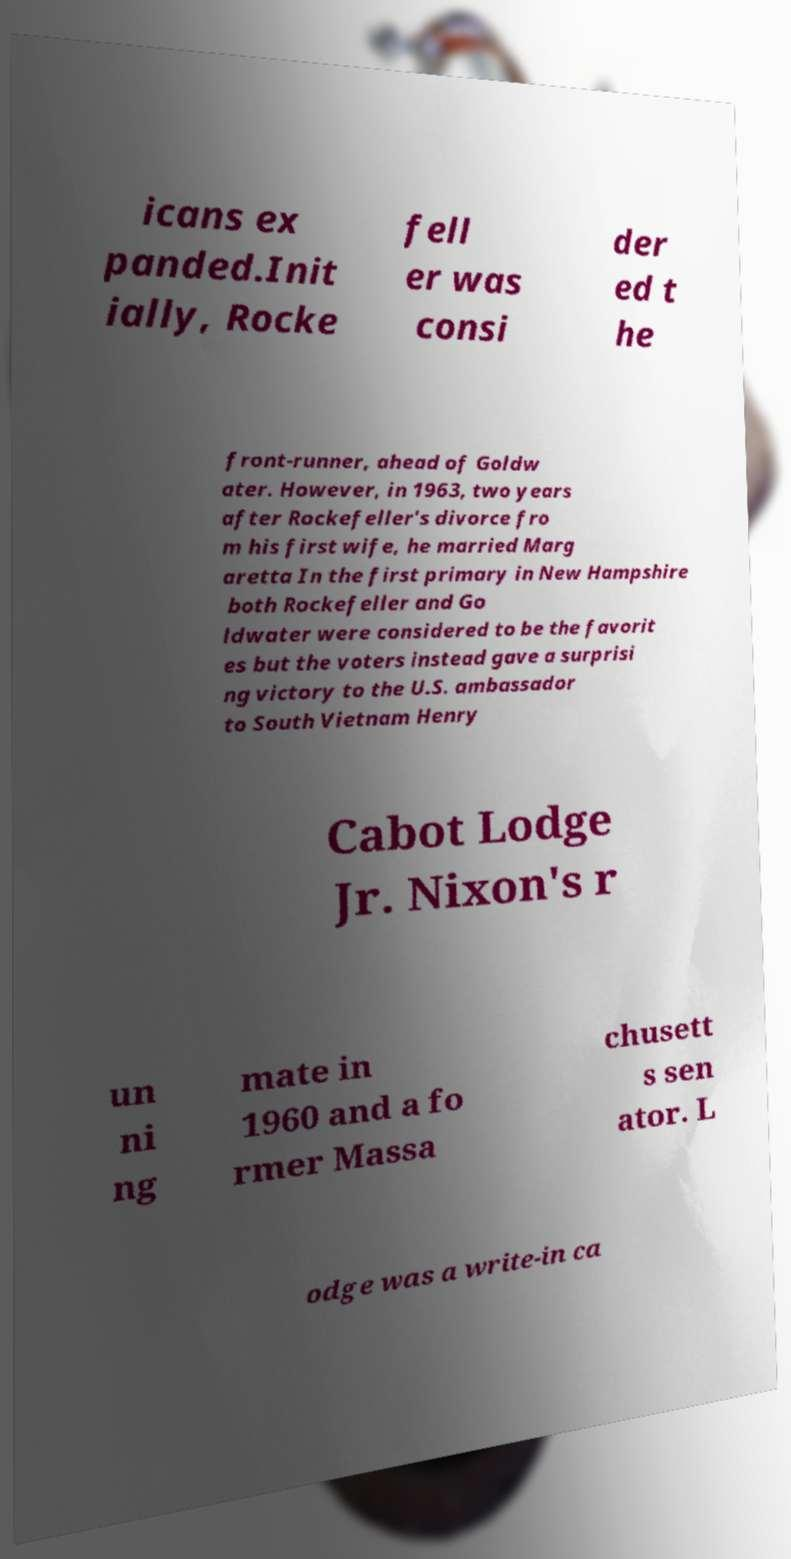Could you extract and type out the text from this image? icans ex panded.Init ially, Rocke fell er was consi der ed t he front-runner, ahead of Goldw ater. However, in 1963, two years after Rockefeller's divorce fro m his first wife, he married Marg aretta In the first primary in New Hampshire both Rockefeller and Go ldwater were considered to be the favorit es but the voters instead gave a surprisi ng victory to the U.S. ambassador to South Vietnam Henry Cabot Lodge Jr. Nixon's r un ni ng mate in 1960 and a fo rmer Massa chusett s sen ator. L odge was a write-in ca 